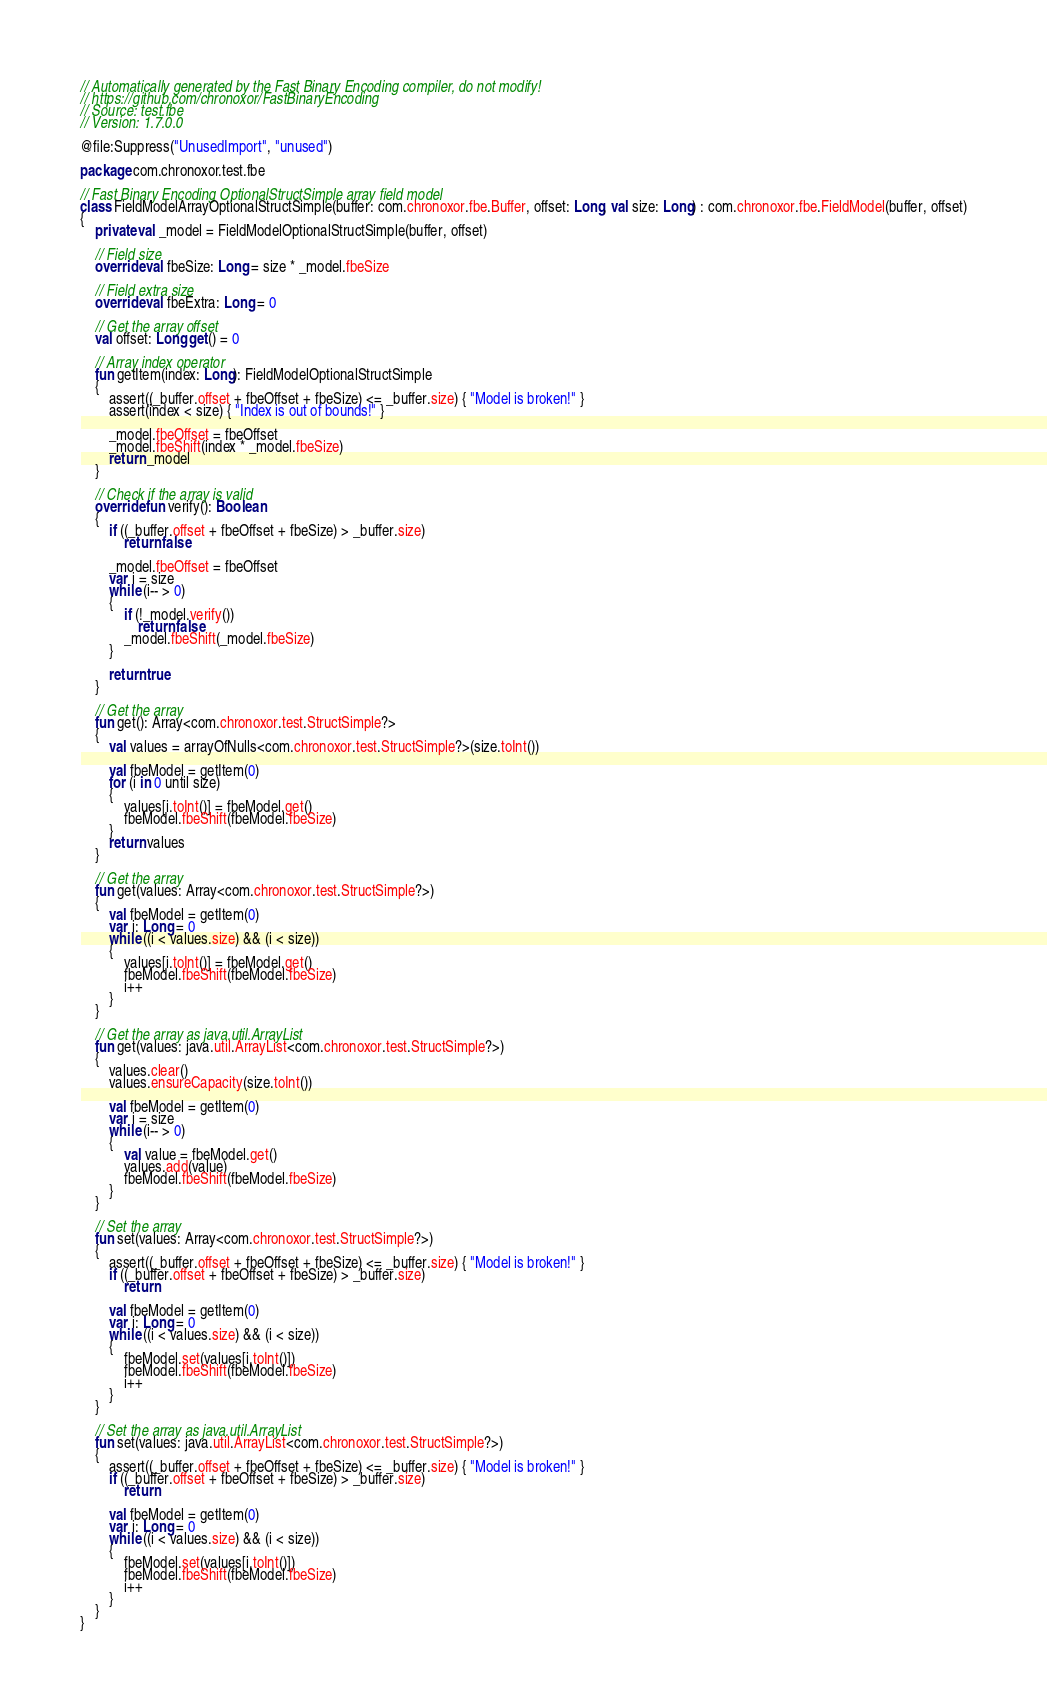<code> <loc_0><loc_0><loc_500><loc_500><_Kotlin_>// Automatically generated by the Fast Binary Encoding compiler, do not modify!
// https://github.com/chronoxor/FastBinaryEncoding
// Source: test.fbe
// Version: 1.7.0.0

@file:Suppress("UnusedImport", "unused")

package com.chronoxor.test.fbe

// Fast Binary Encoding OptionalStructSimple array field model
class FieldModelArrayOptionalStructSimple(buffer: com.chronoxor.fbe.Buffer, offset: Long, val size: Long) : com.chronoxor.fbe.FieldModel(buffer, offset)
{
    private val _model = FieldModelOptionalStructSimple(buffer, offset)

    // Field size
    override val fbeSize: Long = size * _model.fbeSize

    // Field extra size
    override val fbeExtra: Long = 0

    // Get the array offset
    val offset: Long get() = 0

    // Array index operator
    fun getItem(index: Long): FieldModelOptionalStructSimple
    {
        assert((_buffer.offset + fbeOffset + fbeSize) <= _buffer.size) { "Model is broken!" }
        assert(index < size) { "Index is out of bounds!" }

        _model.fbeOffset = fbeOffset
        _model.fbeShift(index * _model.fbeSize)
        return _model
    }

    // Check if the array is valid
    override fun verify(): Boolean
    {
        if ((_buffer.offset + fbeOffset + fbeSize) > _buffer.size)
            return false

        _model.fbeOffset = fbeOffset
        var i = size
        while (i-- > 0)
        {
            if (!_model.verify())
                return false
            _model.fbeShift(_model.fbeSize)
        }

        return true
    }

    // Get the array
    fun get(): Array<com.chronoxor.test.StructSimple?>
    {
        val values = arrayOfNulls<com.chronoxor.test.StructSimple?>(size.toInt())

        val fbeModel = getItem(0)
        for (i in 0 until size)
        {
            values[i.toInt()] = fbeModel.get()
            fbeModel.fbeShift(fbeModel.fbeSize)
        }
        return values
    }

    // Get the array
    fun get(values: Array<com.chronoxor.test.StructSimple?>)
    {
        val fbeModel = getItem(0)
        var i: Long = 0
        while ((i < values.size) && (i < size))
        {
            values[i.toInt()] = fbeModel.get()
            fbeModel.fbeShift(fbeModel.fbeSize)
            i++
        }
    }

    // Get the array as java.util.ArrayList
    fun get(values: java.util.ArrayList<com.chronoxor.test.StructSimple?>)
    {
        values.clear()
        values.ensureCapacity(size.toInt())

        val fbeModel = getItem(0)
        var i = size
        while (i-- > 0)
        {
            val value = fbeModel.get()
            values.add(value)
            fbeModel.fbeShift(fbeModel.fbeSize)
        }
    }

    // Set the array
    fun set(values: Array<com.chronoxor.test.StructSimple?>)
    {
        assert((_buffer.offset + fbeOffset + fbeSize) <= _buffer.size) { "Model is broken!" }
        if ((_buffer.offset + fbeOffset + fbeSize) > _buffer.size)
            return

        val fbeModel = getItem(0)
        var i: Long = 0
        while ((i < values.size) && (i < size))
        {
            fbeModel.set(values[i.toInt()])
            fbeModel.fbeShift(fbeModel.fbeSize)
            i++
        }
    }

    // Set the array as java.util.ArrayList
    fun set(values: java.util.ArrayList<com.chronoxor.test.StructSimple?>)
    {
        assert((_buffer.offset + fbeOffset + fbeSize) <= _buffer.size) { "Model is broken!" }
        if ((_buffer.offset + fbeOffset + fbeSize) > _buffer.size)
            return

        val fbeModel = getItem(0)
        var i: Long = 0
        while ((i < values.size) && (i < size))
        {
            fbeModel.set(values[i.toInt()])
            fbeModel.fbeShift(fbeModel.fbeSize)
            i++
        }
    }
}
</code> 